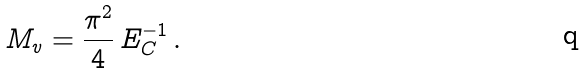Convert formula to latex. <formula><loc_0><loc_0><loc_500><loc_500>M _ { v } = \frac { \pi ^ { 2 } } { 4 } \, E _ { C } ^ { - 1 } \, .</formula> 